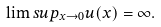<formula> <loc_0><loc_0><loc_500><loc_500>\lim s u p _ { x \to 0 } u ( x ) = \infty .</formula> 